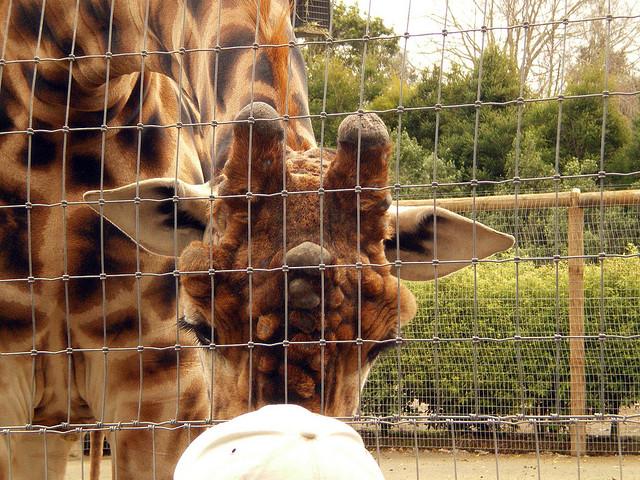What color are the animal's ears?
Write a very short answer. Tan. Is the giraffe inside of a pen?
Concise answer only. Yes. What animal is this?
Quick response, please. Giraffe. 